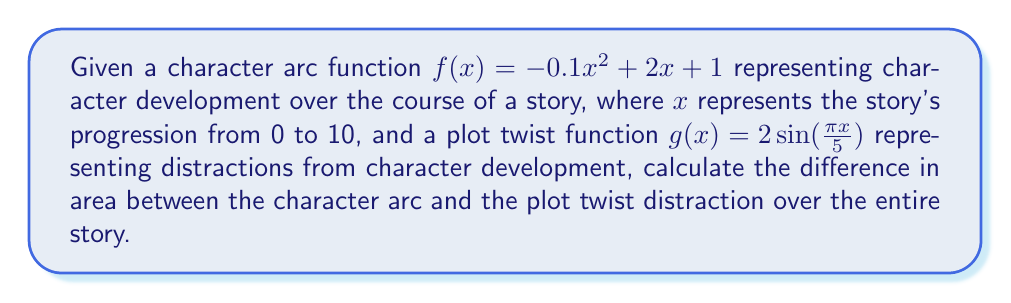Solve this math problem. To solve this problem, we need to:
1. Find the area under the character arc function $f(x)$
2. Find the area under the plot twist function $g(x)$
3. Subtract the plot twist area from the character arc area

Step 1: Area under $f(x)$
$$\int_0^{10} f(x) dx = \int_0^{10} (-0.1x^2 + 2x + 1) dx$$
$$= [-\frac{1}{30}x^3 + x^2 + x]_0^{10}$$
$$= (-\frac{1000}{30} + 100 + 10) - (0 + 0 + 0) = 76.67$$

Step 2: Area under $g(x)$
$$\int_0^{10} g(x) dx = \int_0^{10} 2\sin(\frac{\pi x}{5}) dx$$
$$= -\frac{10}{\pi}[2\cos(\frac{\pi x}{5})]_0^{10}$$
$$= -\frac{10}{\pi}[2\cos(2\pi) - 2\cos(0)] = 0$$

Step 3: Difference in areas
Character arc area - Plot twist area = 76.67 - 0 = 76.67

This result shows that despite the plot twists, the overall character development (represented by the area) is still significant, contradicting the critic's argument that plot twists completely overshadow character development.
Answer: 76.67 